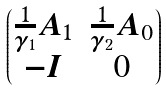Convert formula to latex. <formula><loc_0><loc_0><loc_500><loc_500>\begin{pmatrix} \frac { 1 } { \gamma _ { 1 } } A _ { 1 } & \frac { 1 } { \gamma _ { 2 } } A _ { 0 } \\ - I & 0 \end{pmatrix}</formula> 